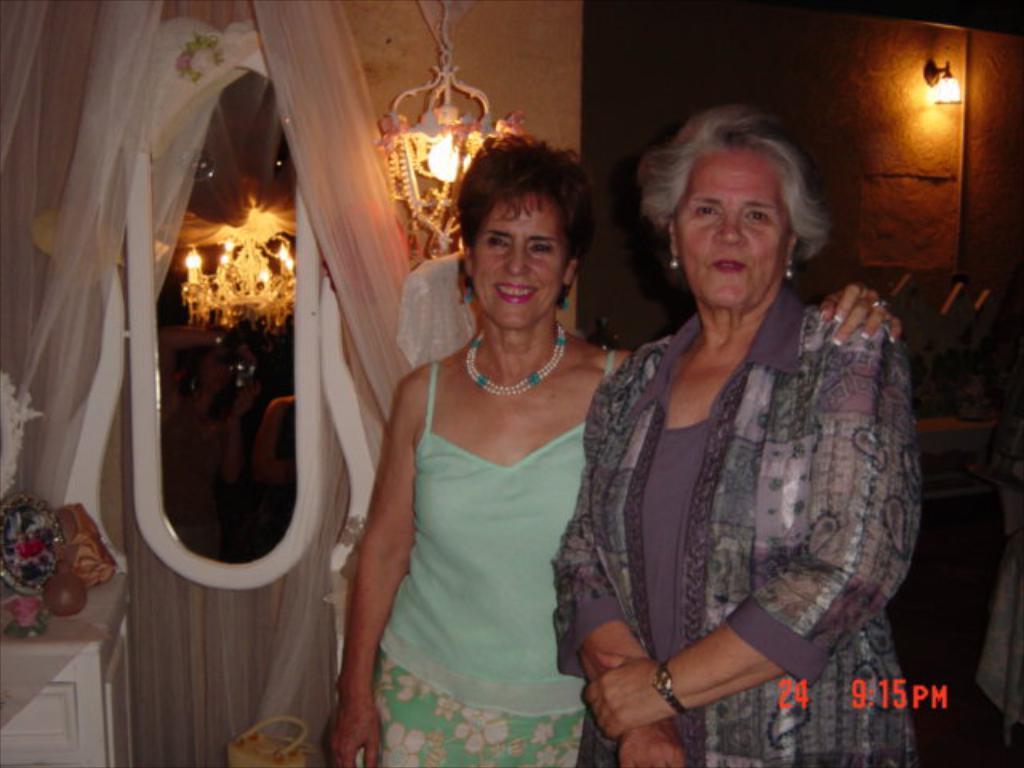Can you describe this image briefly? In this picture we can see two women, they are smiling, here we can see a wall, curtains, chandeliers, lights and some objects, here we can see some text on it. 